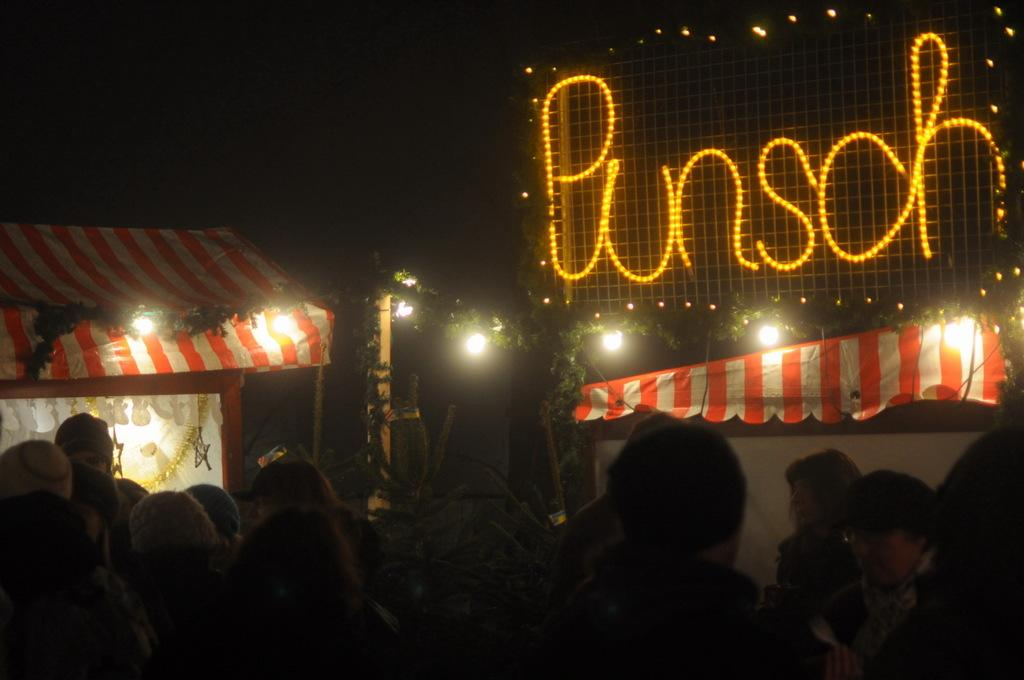Who or what can be seen in the image? There are people in the image. What else is present in the image besides people? There are plants, tents, a pole, lights, and letters on a mesh in the image. Can you describe the setting of the image? The background of the image is dark. What might be the purpose of the pole and lights in the image? The pole and lights could be used for illumination or as part of a temporary structure, such as a campsite. What shape is the good-bye message taking in the image? There is no good-bye message present in the image, so it is not possible to determine its shape. 